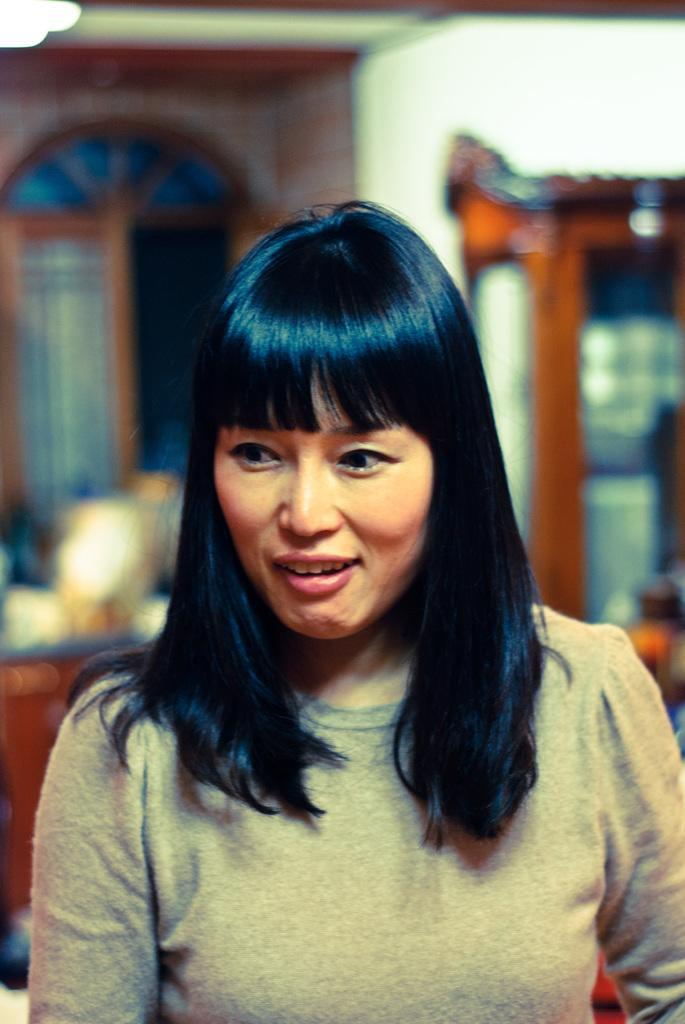Can you describe this image briefly? In this picture we can see a woman. There are wooden objects in the background. 